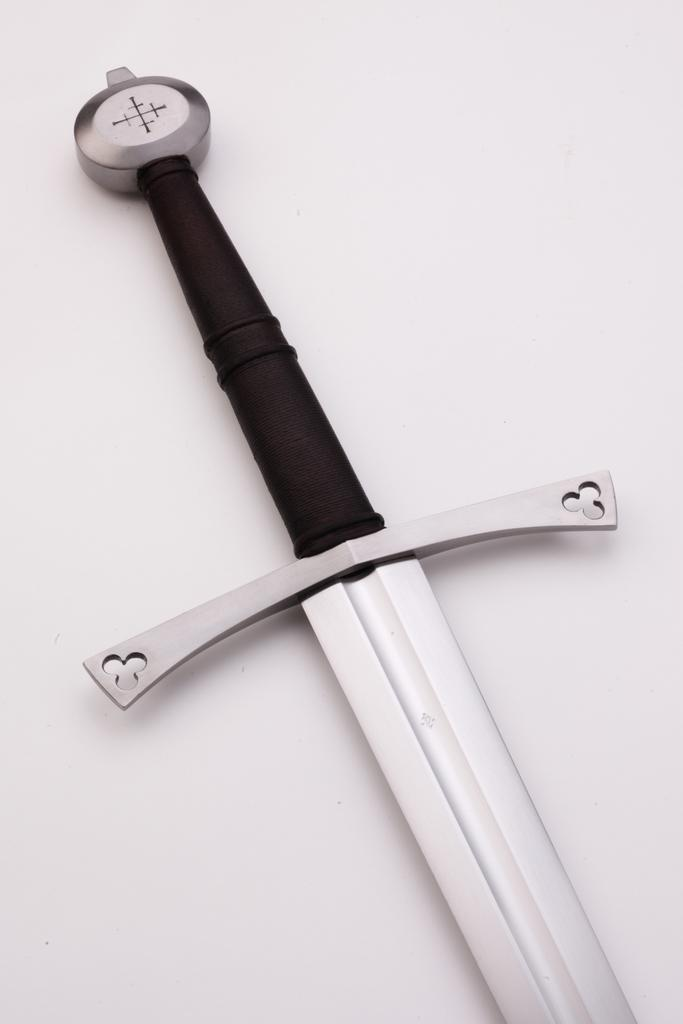What is the main object in the center of the image? There is a sword in the center of the image. What type of produce is being harvested in the image? There is no produce present in the image; it features a sword in the center. What acoustics can be heard in the image? There are no sounds or acoustics present in the image, as it is a still image featuring a sword. 